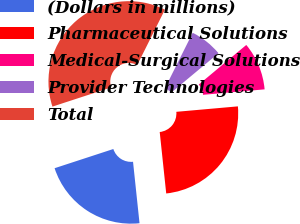Convert chart. <chart><loc_0><loc_0><loc_500><loc_500><pie_chart><fcel>(Dollars in millions)<fcel>Pharmaceutical Solutions<fcel>Medical-Surgical Solutions<fcel>Provider Technologies<fcel>Total<nl><fcel>21.65%<fcel>24.73%<fcel>9.65%<fcel>6.56%<fcel>37.41%<nl></chart> 